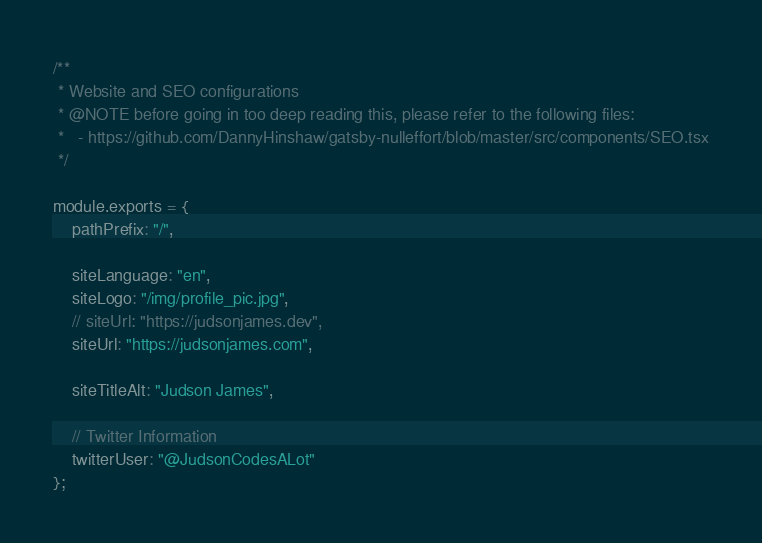<code> <loc_0><loc_0><loc_500><loc_500><_JavaScript_>
/**
 * Website and SEO configurations
 * @NOTE before going in too deep reading this, please refer to the following files:
 *   - https://github.com/DannyHinshaw/gatsby-nulleffort/blob/master/src/components/SEO.tsx
 */

module.exports = {
    pathPrefix: "/",

    siteLanguage: "en",
    siteLogo: "/img/profile_pic.jpg",
    // siteUrl: "https://judsonjames.dev",
    siteUrl: "https://judsonjames.com",

    siteTitleAlt: "Judson James",

    // Twitter Information
    twitterUser: "@JudsonCodesALot"
};
</code> 